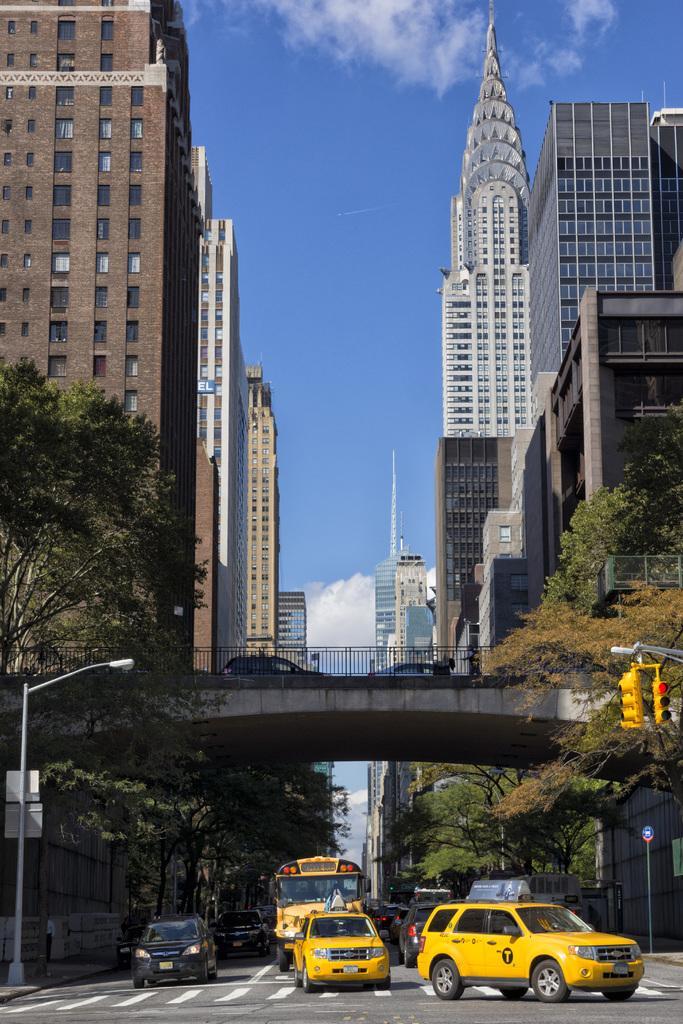Can you describe this image briefly? In this picture I can see vehicles on the road, there are poles, boards, traffic signal lights, bridge, buildings, trees, and in the background there is sky. 